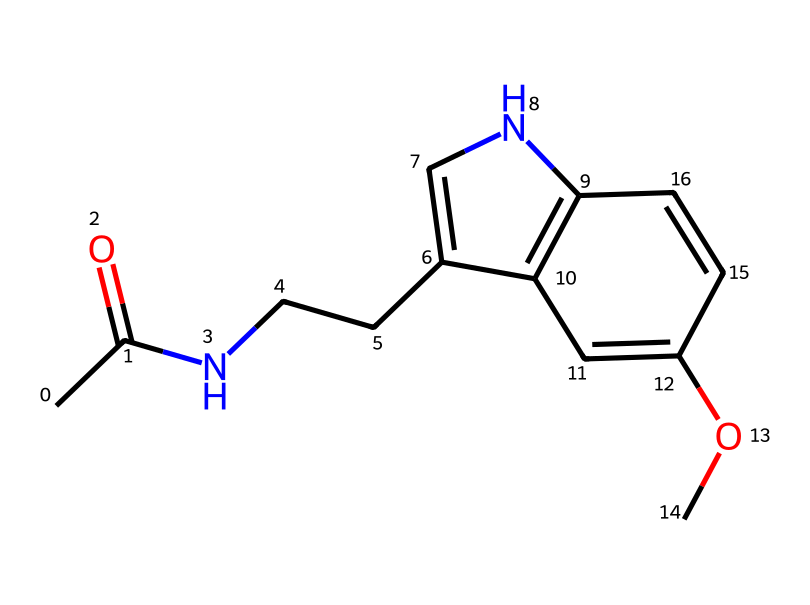What is the molecular formula of this compound? To determine the molecular formula, count the number of each type of atom in the structure represented by the SMILES notation. The structure contains 12 carbon atoms (C), 15 hydrogen atoms (H), 1 nitrogen atom (N), and 3 oxygen atoms (O). Thus, the molecular formula is C12H15N1O3.
Answer: C12H15N1O3 How many rings are present in the structure? By examining the structural connectivity in the SMILES, we can identify that there are two cyclic (ring) structures in the compound. The notation indicates two closed loops formed by the bonds.
Answer: 2 What type of functional groups are present in this compound? The SMILES indicates the presence of both an amide (the nitrogen bonded to a carbonyl carbon), and a methoxy group (–OCH3) attached to the ring. Amides are characterized by the –C(=O)N– bond, and methoxy indicates the –O–C bond. Thus, the functional groups include amide and ether.
Answer: amide and ether What does the nitrogen atom indicate about the bonding in the compound? The nitrogen atom is connected to carbon and is likely involved in a resonance structure because of its ability to share electrons (due to its lone pair). This suggests that the compound may have some basic character due to the nitrogen's role in stabilizing positive charges, which is common in imides and related structures.
Answer: resonance stabilizes How many oxygen atoms are involved in the structure? From counting the oxygen atoms in the SMILES representation, we can see that there are three oxygen atoms, two of which are part of the carbonyl and one in the methoxy group.
Answer: 3 What is the significance of the methoxy group in the structure? The methoxy group (–OCH3) serves as an electron-donating substituent which can influence the chemical properties and biological activity of the compound. It can increase solubility and alter the pharmacokinetics of the molecule, impacting how it interacts with receptors in the body.
Answer: electron-donating group 